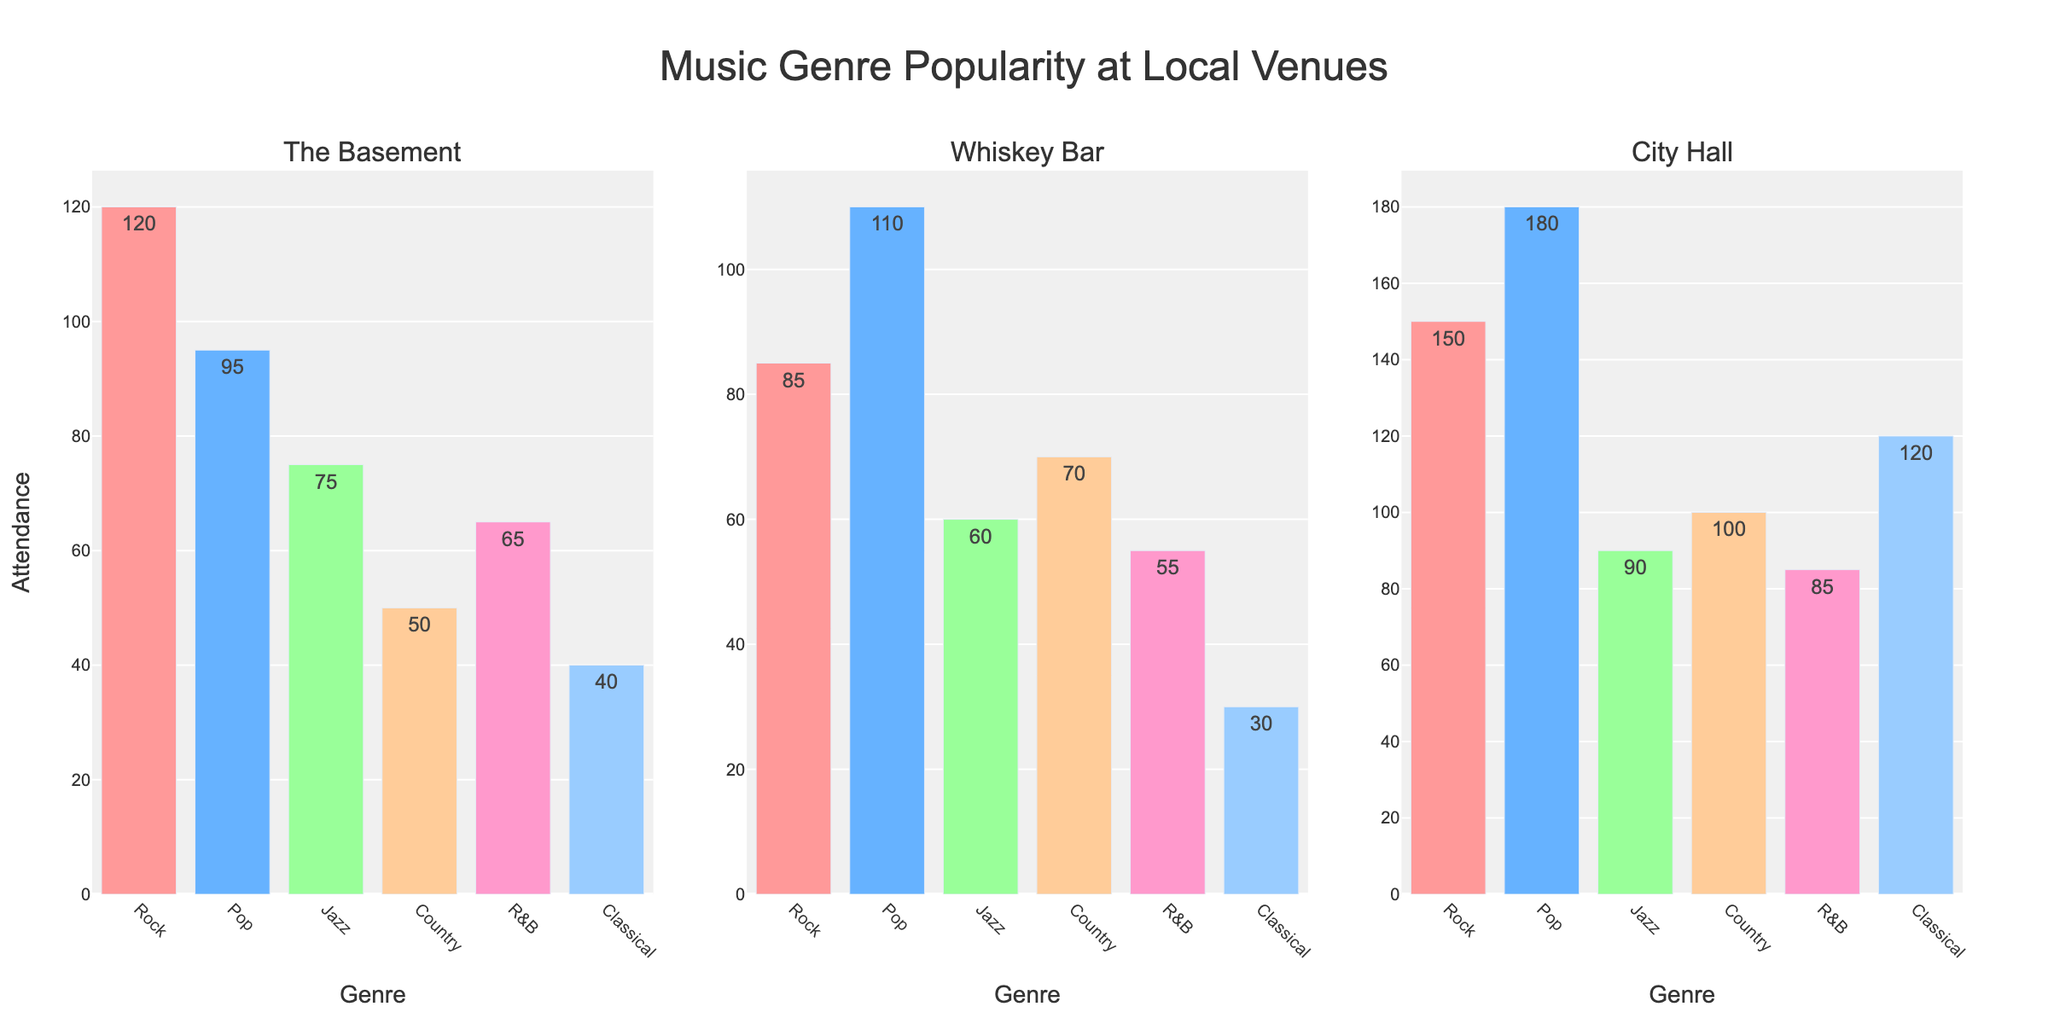What's the title of the figure? The title of the figure is displayed at the top of the plot. It reads "Music Genre Popularity at Local Venues".
Answer: Music Genre Popularity at Local Venues Which venue has the highest attendance for the Pop genre? By inspecting each bar plot for the Pop genre across all venues, City Hall has the highest attendance for Pop with a height corresponding to 180.
Answer: City Hall What is the total attendance for Rock genre across all venues? To find the total attendance, add the attendance numbers for Rock at each venue. \(120 + 85 + 150 = 355\).
Answer: 355 Which genre has the lowest attendance at The Basement venue? By examining the heights of the bars at The Basement, Classical has the lowest attendance with a value of 40.
Answer: Classical Compare the attendance for Rock at City Hall and Whiskey Bar. Which one is higher and by how much? City Hall has 150 for Rock and Whiskey Bar has 85 for Rock. The difference is \(150 - 85 = 65\), with City Hall being higher.
Answer: City Hall by 65 What's the average attendance for Jazz across all venues? Sum the attendance for Jazz across all venues and divide by the number of venues (3). \((75 + 60 + 90) / 3 = 75\).
Answer: 75 Which genre at Whiskey Bar has the closest attendance to 55? Looking at the bars at Whiskey Bar, the attendance of 55 matches exactly with R&B.
Answer: R&B Which venue has the most consistent attendance across all genres (smallest range between highest and lowest attendance)? Calculate the range for each venue:
- The Basement: \(120 - 40 = 80\)
- Whiskey Bar: \(110 - 30 = 80\)
- City Hall: \(180 - 85 = 95\)
Both The Basement and Whiskey Bar have the smallest and equal range.
Answer: The Basement and Whiskey Bar How much higher is the attendance for Classical at City Hall compared to The Basement? Compare the attendance numbers for Classical at City Hall (120) and The Basement (40). \((120 - 40 = 80)\).
Answer: 80 